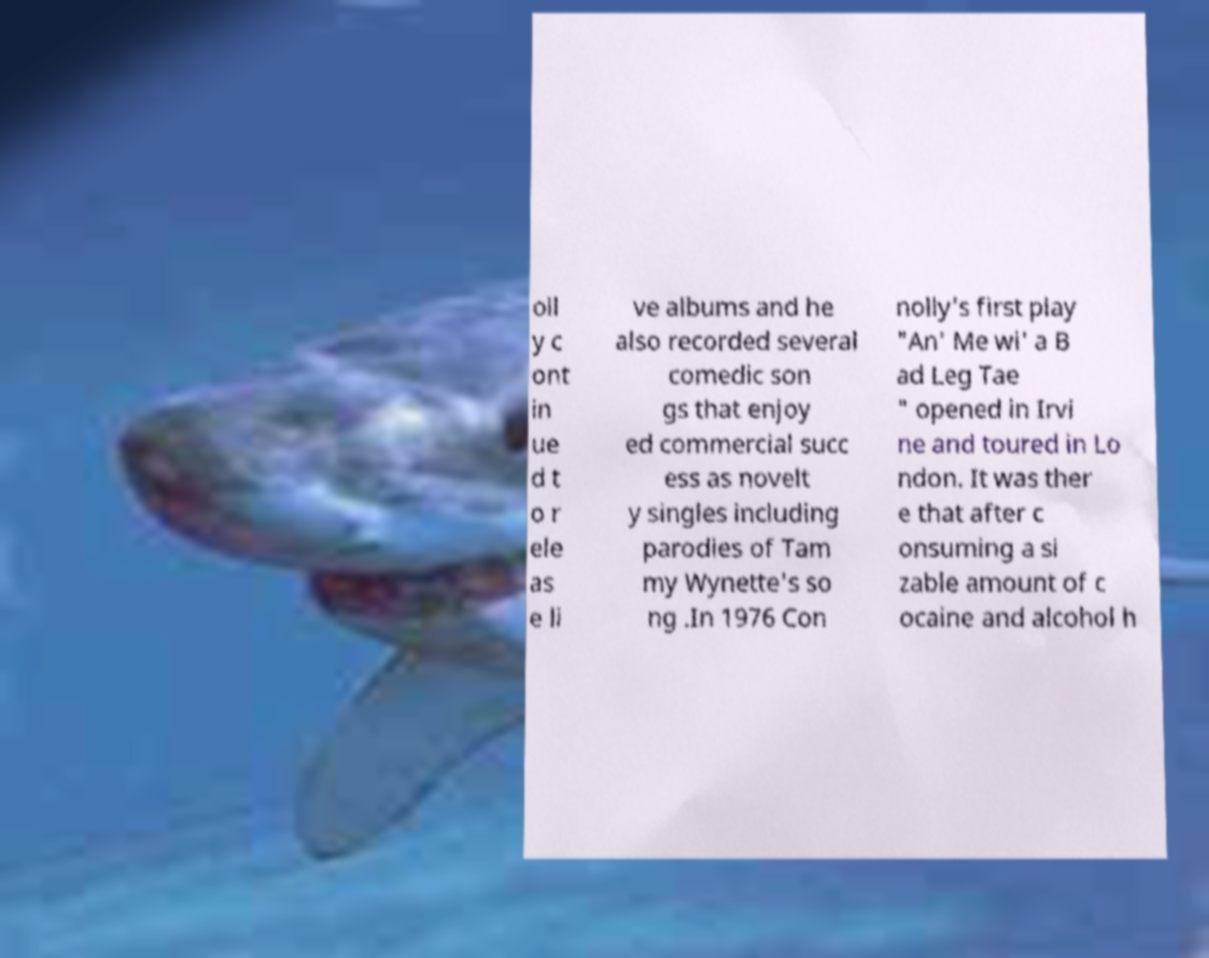I need the written content from this picture converted into text. Can you do that? oll y c ont in ue d t o r ele as e li ve albums and he also recorded several comedic son gs that enjoy ed commercial succ ess as novelt y singles including parodies of Tam my Wynette's so ng .In 1976 Con nolly's first play "An' Me wi' a B ad Leg Tae " opened in Irvi ne and toured in Lo ndon. It was ther e that after c onsuming a si zable amount of c ocaine and alcohol h 